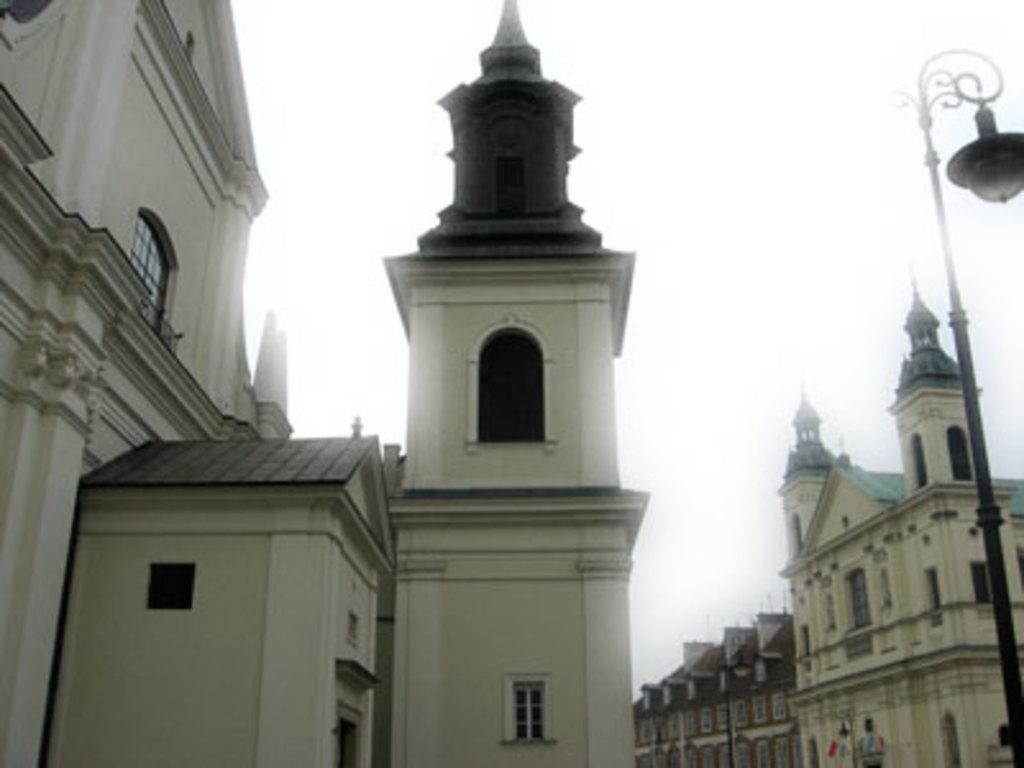What type of structures can be seen in the image? There are buildings in the image. What is attached to the pole in the image? There is a light attached to the pole in the image. What part of the natural environment is visible in the image? The sky is visible in the image. How many geese are sitting on the library bean in the image? There are no geese or library bean present in the image. 